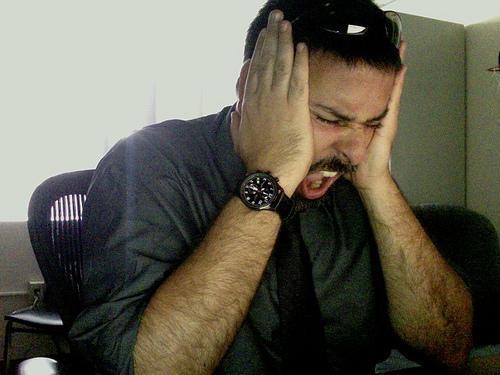How many people are visible?
Give a very brief answer. 1. 